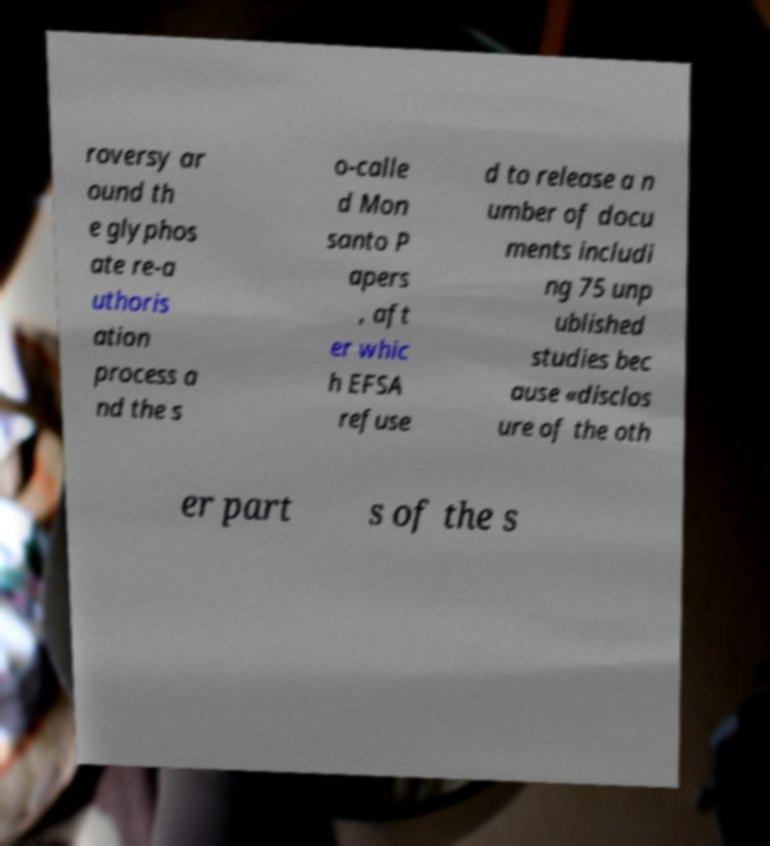Please identify and transcribe the text found in this image. roversy ar ound th e glyphos ate re-a uthoris ation process a nd the s o-calle d Mon santo P apers , aft er whic h EFSA refuse d to release a n umber of docu ments includi ng 75 unp ublished studies bec ause «disclos ure of the oth er part s of the s 